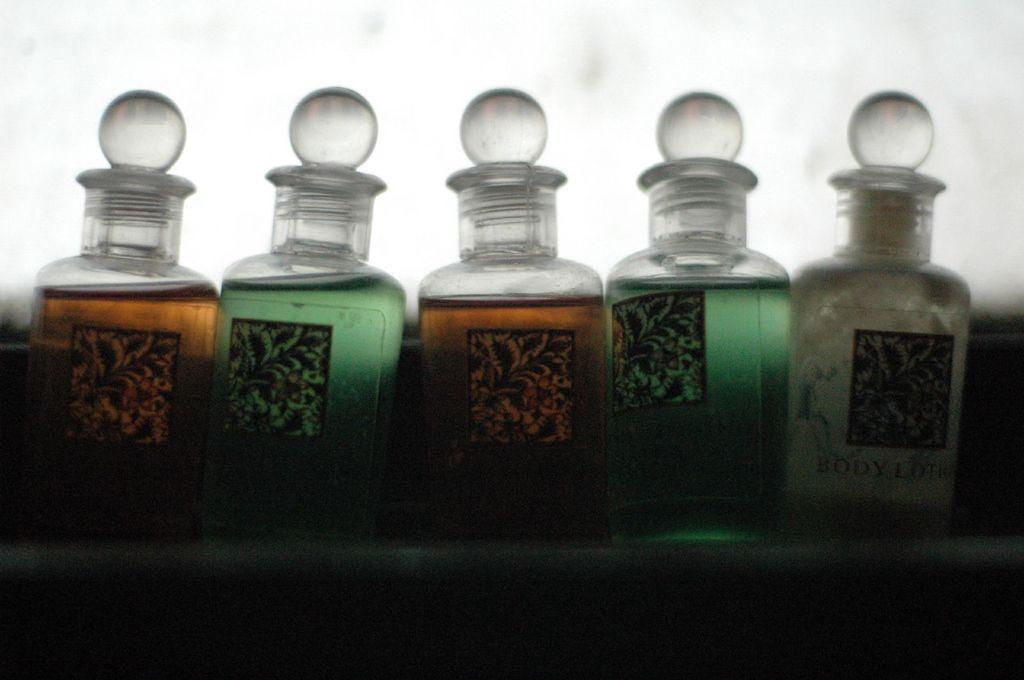<image>
Create a compact narrative representing the image presented. Several glass containers of body lotion are lined up next to each other. 